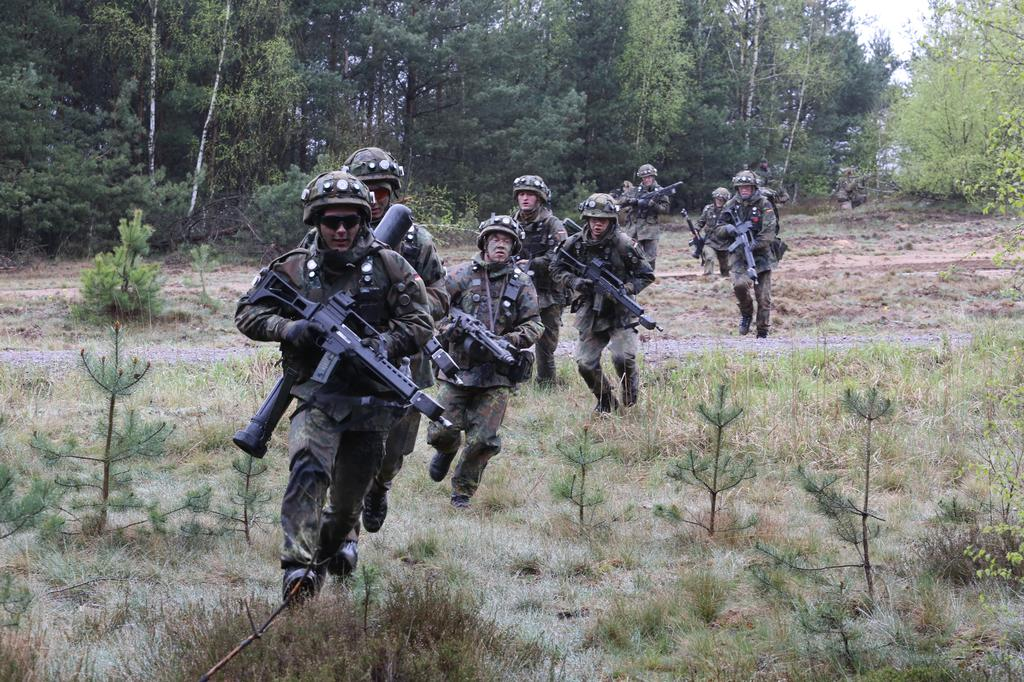What are the people in the image holding? The people in the image are holding guns. What are the people doing while holding the guns? The people are running in the ground. What can be seen in the background of the image? There are trees and the sky visible in the background of the image. What type of home can be seen in the image? There is no home present in the image. What structure is visible in the image? The image does not show any specific structures besides the trees and people holding guns. 